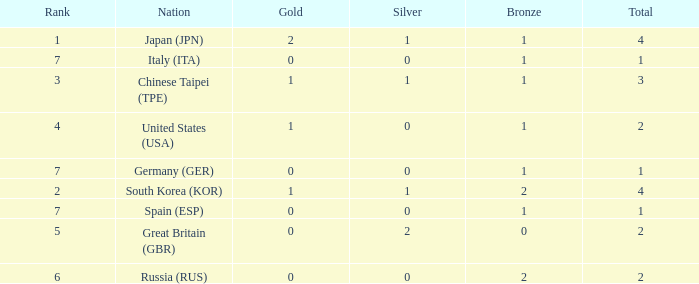How many total medals does a country with more than 1 silver medals have? 2.0. 